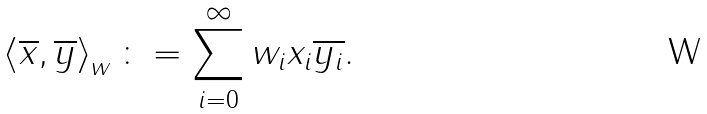<formula> <loc_0><loc_0><loc_500><loc_500>\left \langle \overline { x } , \overline { y } \right \rangle _ { w } \colon = \sum _ { i = 0 } ^ { \infty } w _ { i } x _ { i } \overline { y _ { i } } .</formula> 